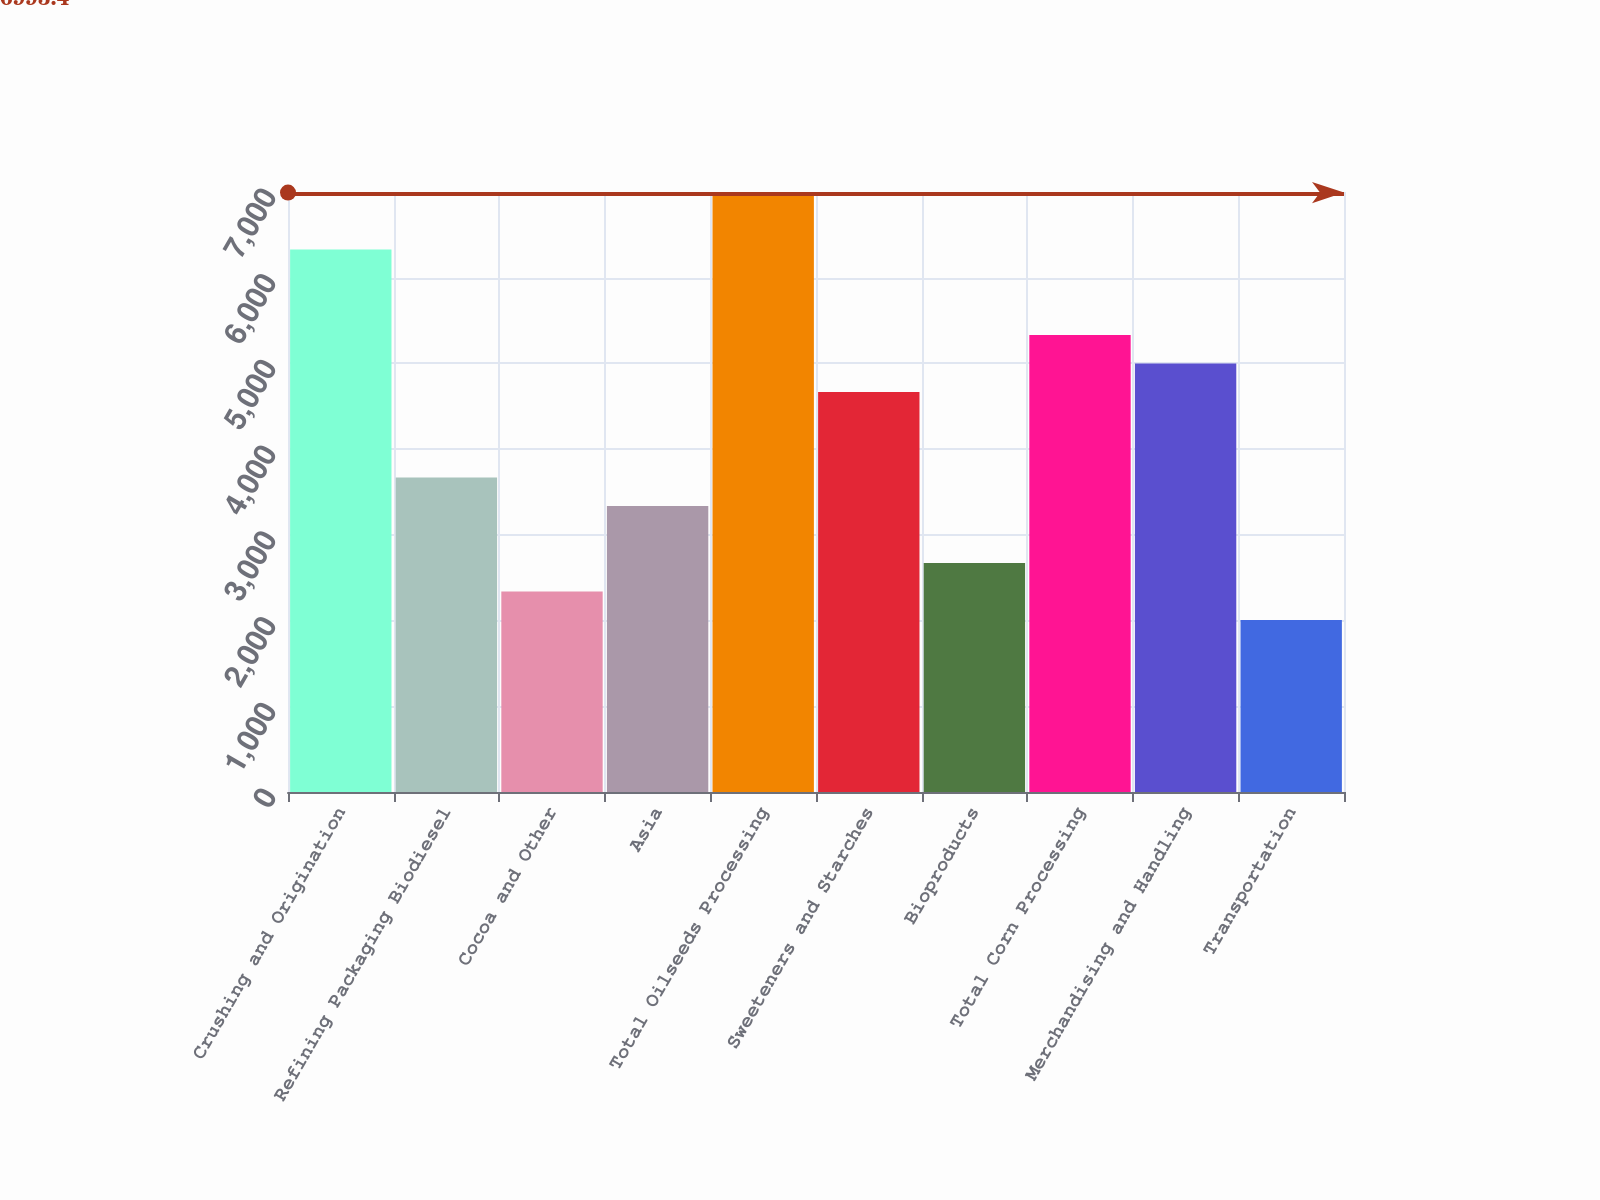<chart> <loc_0><loc_0><loc_500><loc_500><bar_chart><fcel>Crushing and Origination<fcel>Refining Packaging Biodiesel<fcel>Cocoa and Other<fcel>Asia<fcel>Total Oilseeds Processing<fcel>Sweeteners and Starches<fcel>Bioproducts<fcel>Total Corn Processing<fcel>Merchandising and Handling<fcel>Transportation<nl><fcel>6328.6<fcel>3669.4<fcel>2339.8<fcel>3337<fcel>6993.4<fcel>4666.6<fcel>2672.2<fcel>5331.4<fcel>4999<fcel>2007.4<nl></chart> 